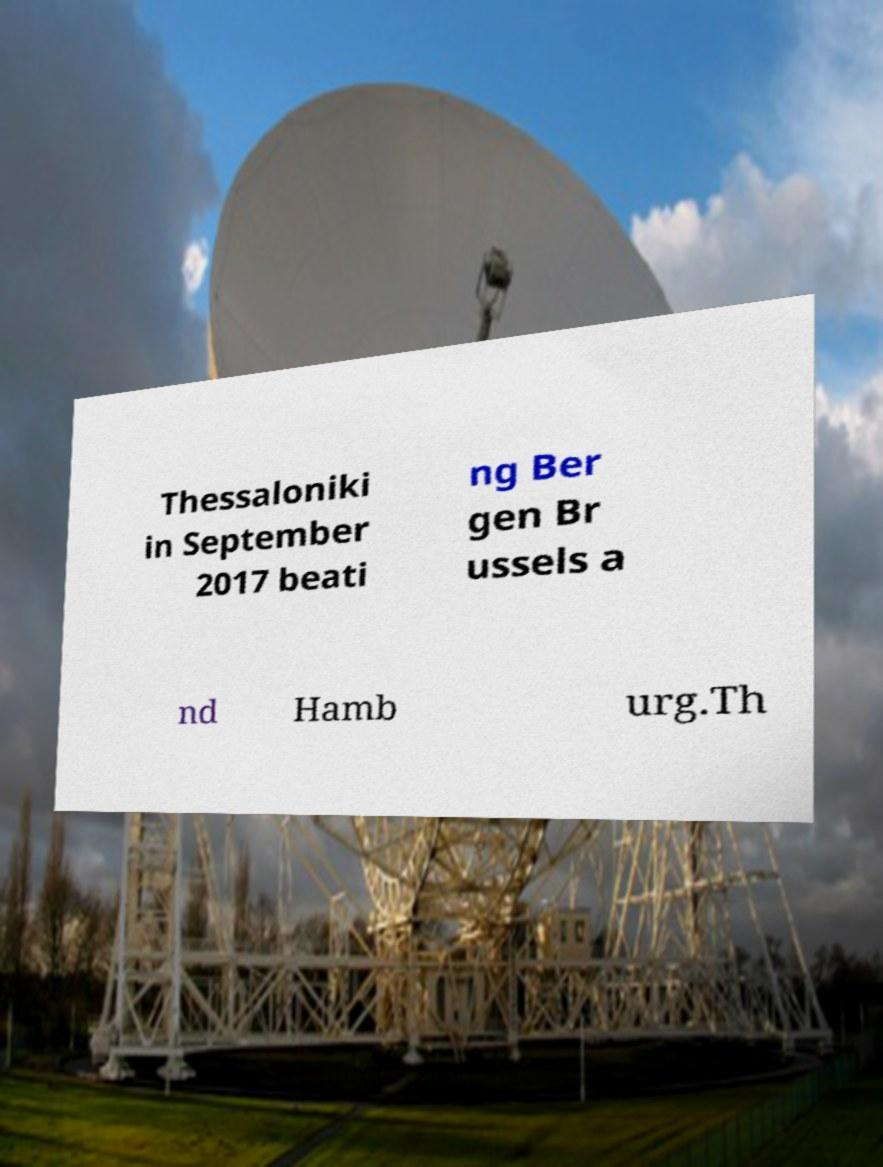For documentation purposes, I need the text within this image transcribed. Could you provide that? Thessaloniki in September 2017 beati ng Ber gen Br ussels a nd Hamb urg.Th 